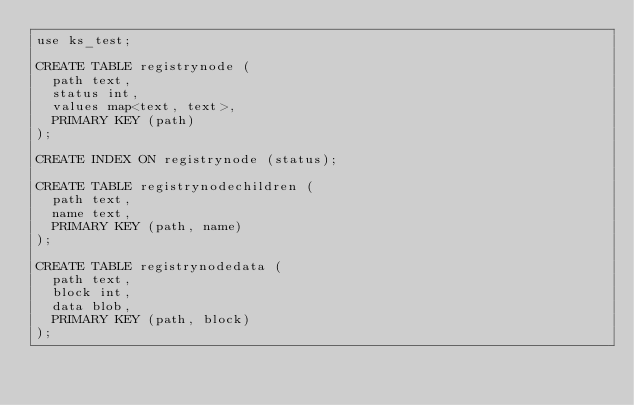Convert code to text. <code><loc_0><loc_0><loc_500><loc_500><_SQL_>use ks_test;

CREATE TABLE registrynode (
  path text,
  status int,
  values map<text, text>,
  PRIMARY KEY (path)
);

CREATE INDEX ON registrynode (status);

CREATE TABLE registrynodechildren (
  path text,
  name text,
  PRIMARY KEY (path, name)
);

CREATE TABLE registrynodedata (
  path text,
  block int,
  data blob,
  PRIMARY KEY (path, block)
);
</code> 